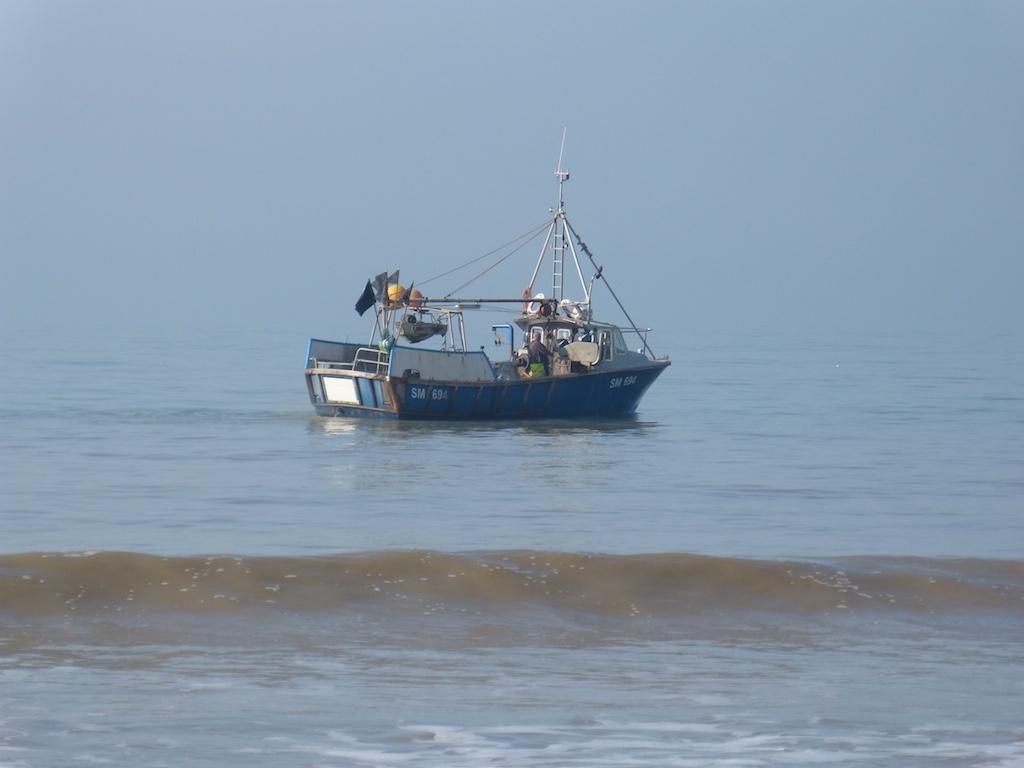In one or two sentences, can you explain what this image depicts? We can see ship above the water. We can see poles and ropes. In the background we can see sky. 